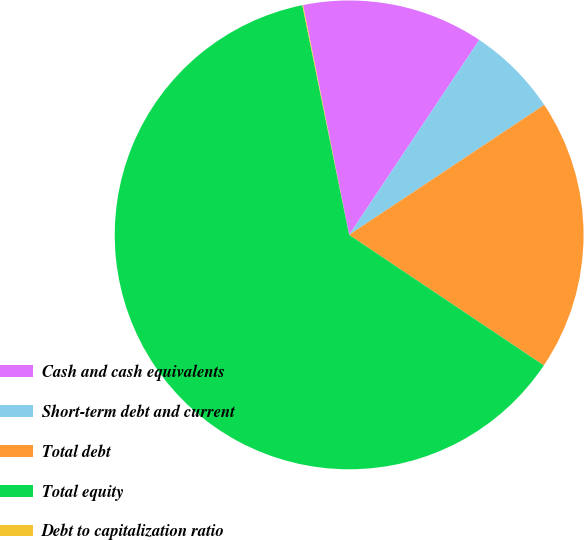Convert chart. <chart><loc_0><loc_0><loc_500><loc_500><pie_chart><fcel>Cash and cash equivalents<fcel>Short-term debt and current<fcel>Total debt<fcel>Total equity<fcel>Debt to capitalization ratio<nl><fcel>12.52%<fcel>6.28%<fcel>18.75%<fcel>62.4%<fcel>0.05%<nl></chart> 